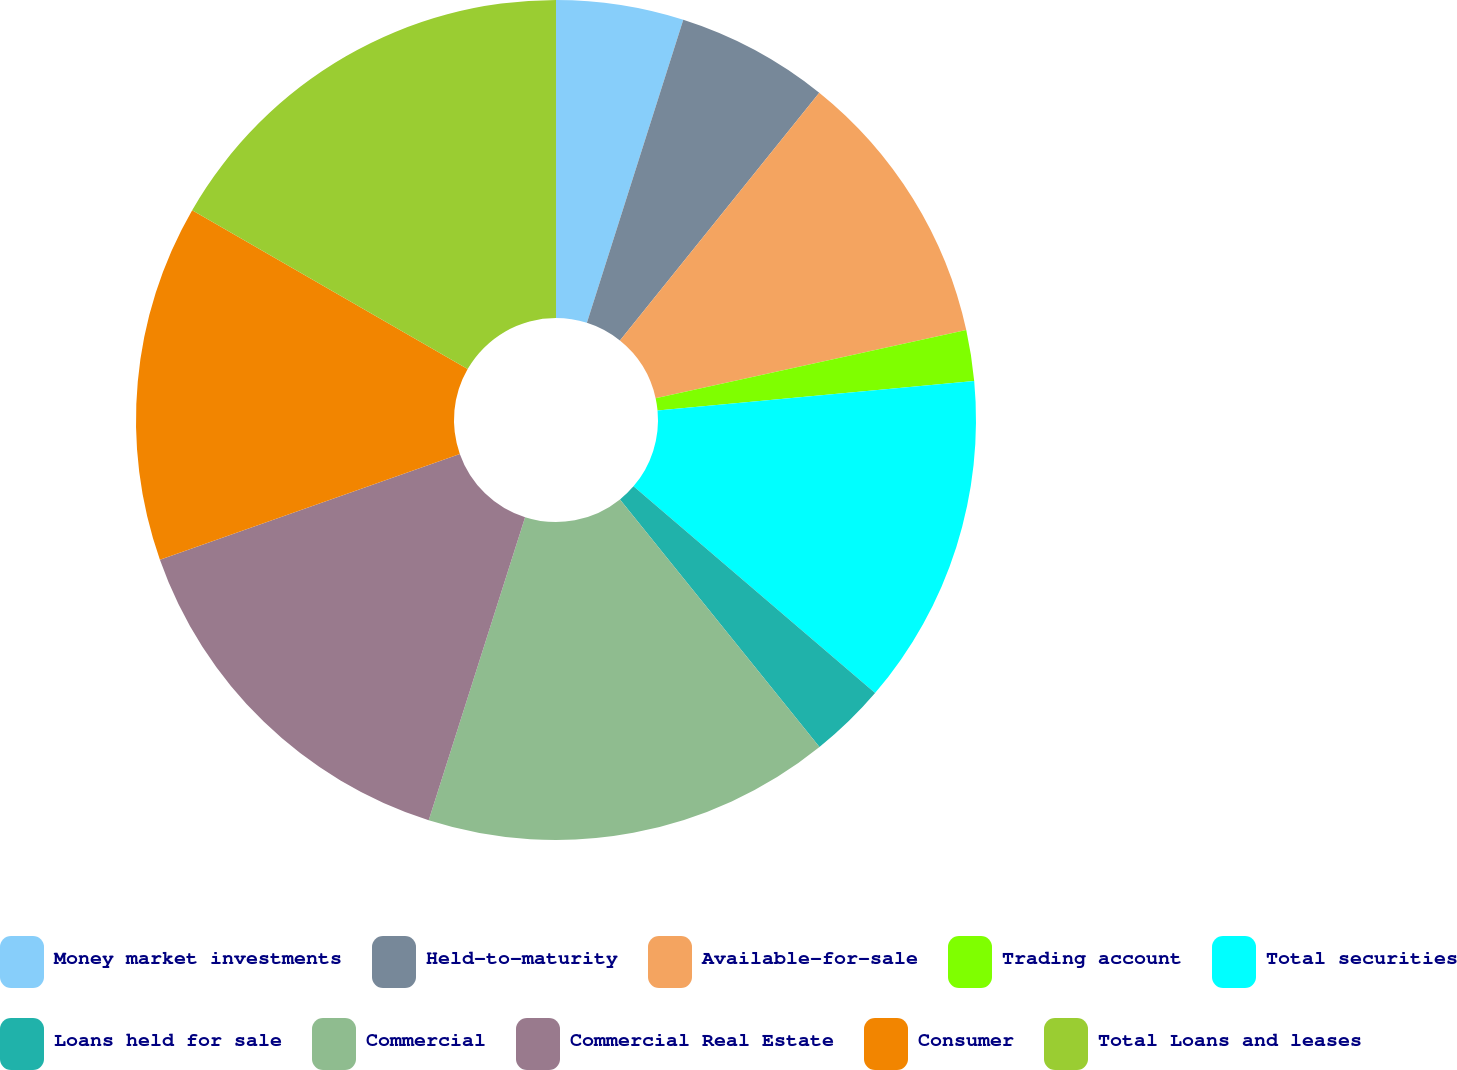<chart> <loc_0><loc_0><loc_500><loc_500><pie_chart><fcel>Money market investments<fcel>Held-to-maturity<fcel>Available-for-sale<fcel>Trading account<fcel>Total securities<fcel>Loans held for sale<fcel>Commercial<fcel>Commercial Real Estate<fcel>Consumer<fcel>Total Loans and leases<nl><fcel>4.9%<fcel>5.88%<fcel>10.78%<fcel>1.96%<fcel>12.74%<fcel>2.94%<fcel>15.69%<fcel>14.7%<fcel>13.72%<fcel>16.67%<nl></chart> 